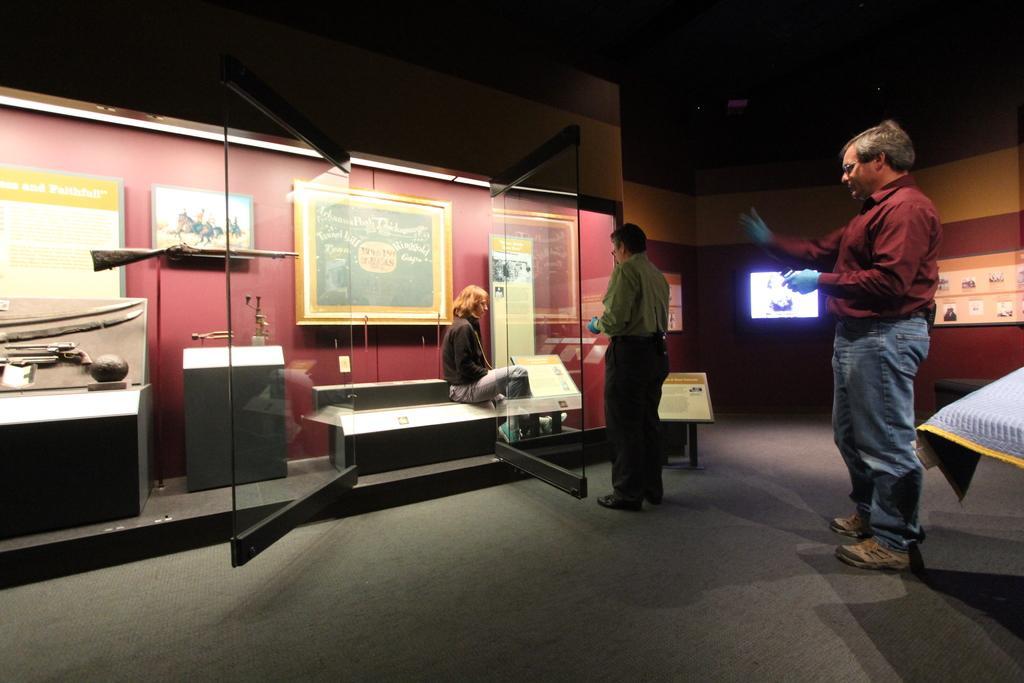Describe this image in one or two sentences. In the picture I can see two men are standing on the floor and one woman is sitting. I can also see glass doors, red color walls which has boards attached to them. Here I can see I can a gun, swords and some other objects on the floor. 